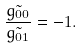<formula> <loc_0><loc_0><loc_500><loc_500>\frac { \tilde { g _ { 0 0 } } } { \tilde { g _ { 0 1 } } } = - 1 .</formula> 